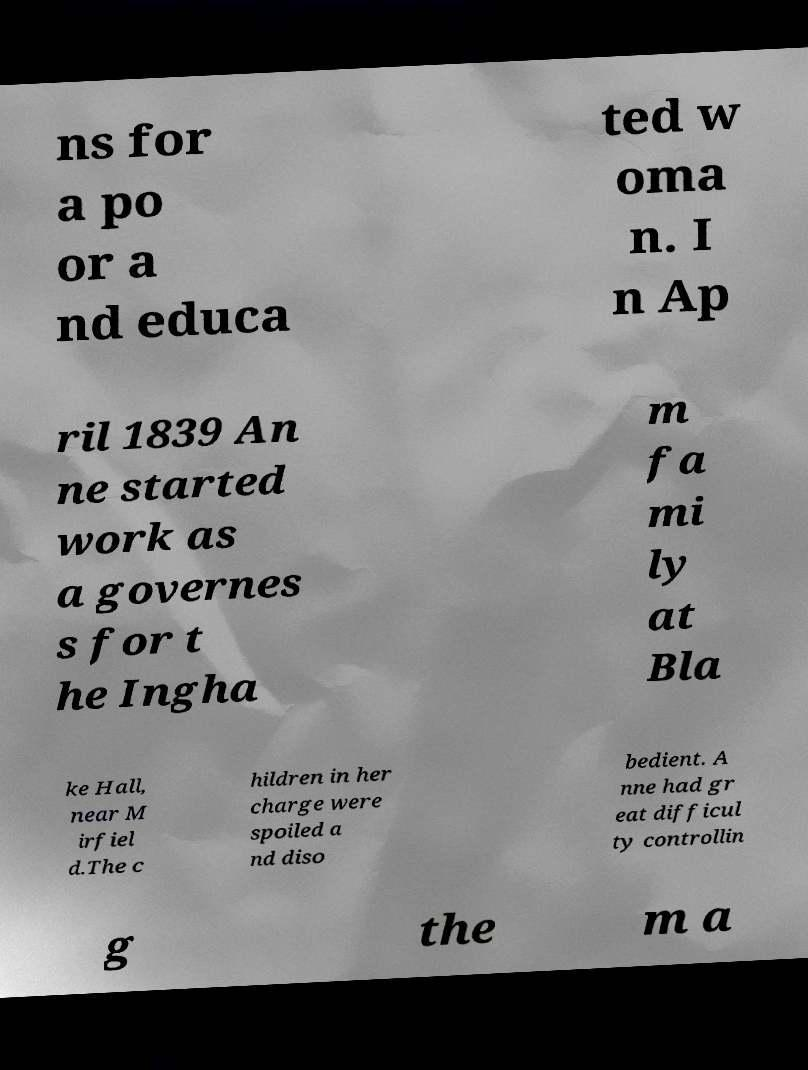Can you read and provide the text displayed in the image?This photo seems to have some interesting text. Can you extract and type it out for me? ns for a po or a nd educa ted w oma n. I n Ap ril 1839 An ne started work as a governes s for t he Ingha m fa mi ly at Bla ke Hall, near M irfiel d.The c hildren in her charge were spoiled a nd diso bedient. A nne had gr eat difficul ty controllin g the m a 